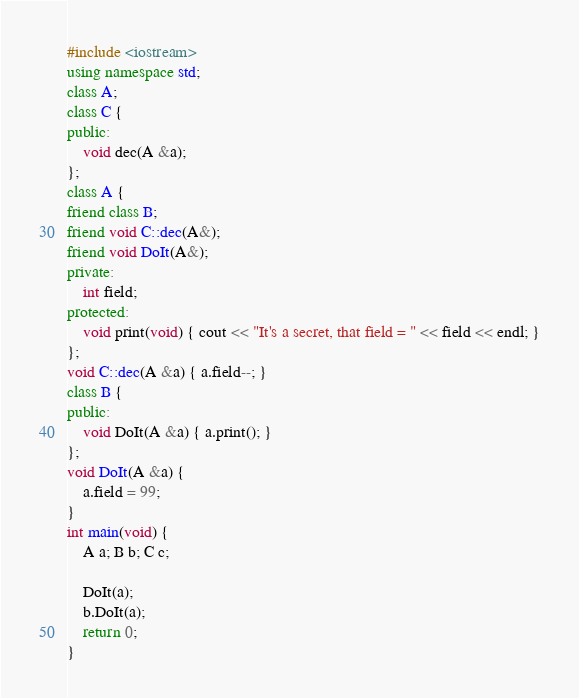<code> <loc_0><loc_0><loc_500><loc_500><_C++_>#include <iostream>
using namespace std;
class A;
class C {
public:
	void dec(A &a);
};
class A {
friend class B;
friend void C::dec(A&);
friend void DoIt(A&);
private:
	int field;
protected:
	void print(void) { cout << "It's a secret, that field = " << field << endl; }
};
void C::dec(A &a) { a.field--; }
class B {
public:
	void DoIt(A &a) { a.print(); }
};
void DoIt(A &a) {
	a.field = 99;
}
int main(void) {
	A a; B b; C c;

	DoIt(a);
	b.DoIt(a);
	return 0;
}
</code> 